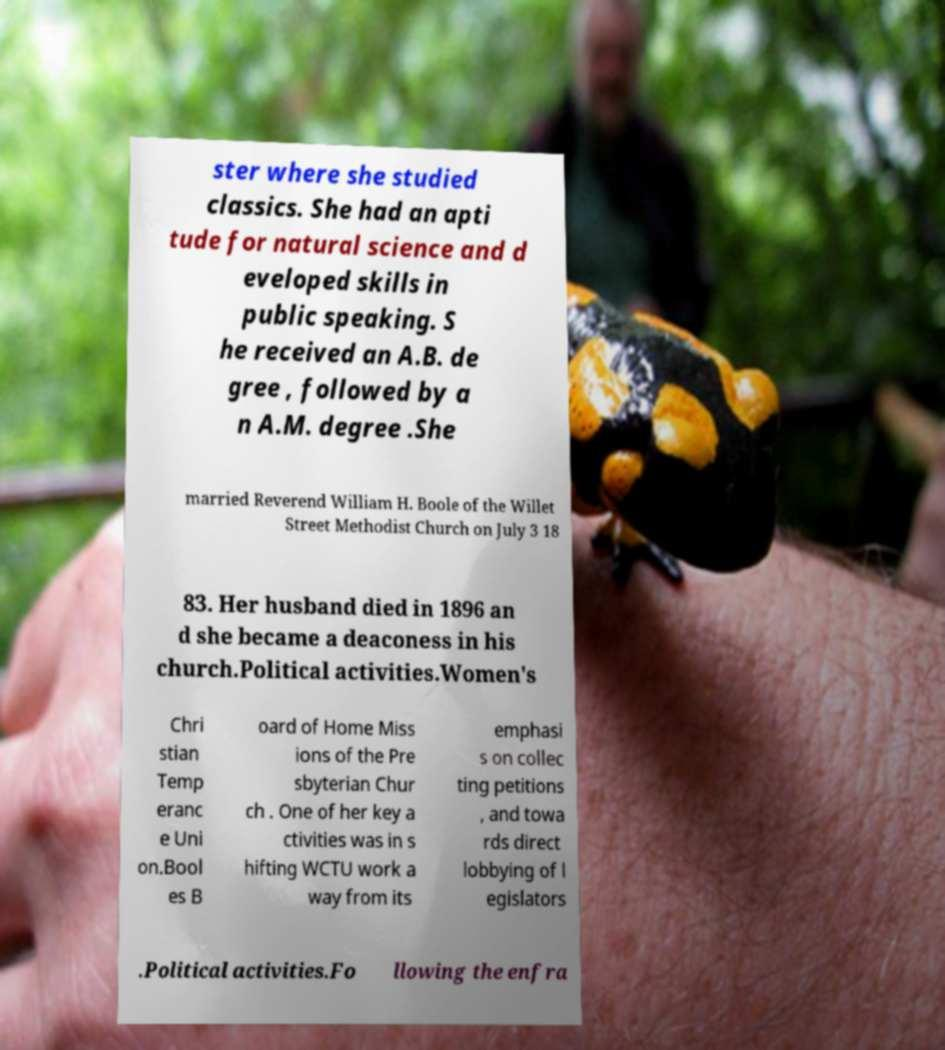Please read and relay the text visible in this image. What does it say? ster where she studied classics. She had an apti tude for natural science and d eveloped skills in public speaking. S he received an A.B. de gree , followed by a n A.M. degree .She married Reverend William H. Boole of the Willet Street Methodist Church on July 3 18 83. Her husband died in 1896 an d she became a deaconess in his church.Political activities.Women's Chri stian Temp eranc e Uni on.Bool es B oard of Home Miss ions of the Pre sbyterian Chur ch . One of her key a ctivities was in s hifting WCTU work a way from its emphasi s on collec ting petitions , and towa rds direct lobbying of l egislators .Political activities.Fo llowing the enfra 